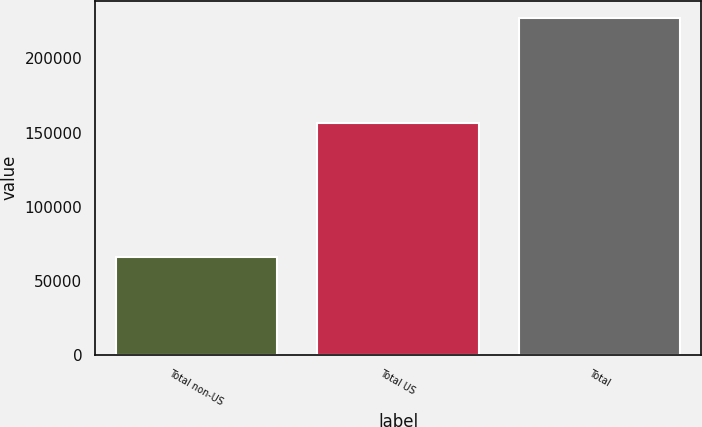Convert chart to OTSL. <chart><loc_0><loc_0><loc_500><loc_500><bar_chart><fcel>Total non-US<fcel>Total US<fcel>Total<nl><fcel>66151<fcel>156359<fcel>227633<nl></chart> 